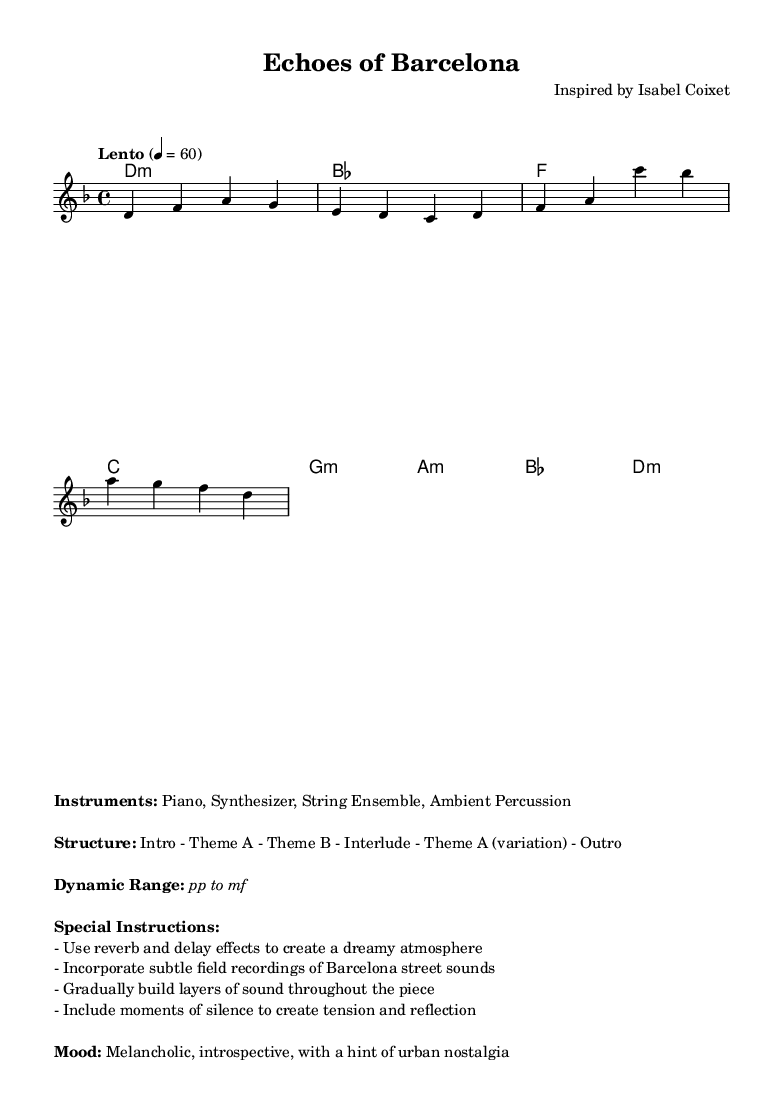What is the key signature of this music? The key signature is D minor, which contains one flat (B flat). This is indicated at the beginning of the staff.
Answer: D minor What is the time signature of this piece? The time signature is 4/4, as visible at the beginning of the score next to the key signature. This means there are four beats in each measure.
Answer: 4/4 What is the tempo indication for this composition? The tempo is marked "Lento," which indicates a slow tempo. The specific metronome marking is 4 = 60, meaning there should be 60 quarter note beats per minute.
Answer: Lento What instruments are specified for this arrangement? The instruments listed include Piano, Synthesizer, String Ensemble, and Ambient Percussion, as detailed in the markup section under "Instruments."
Answer: Piano, Synthesizer, String Ensemble, Ambient Percussion How many sections are in the structure of this piece? The structure includes six sections as outlined: Intro, Theme A, Theme B, Interlude, Theme A (variation), and Outro. This information is outlined in the markup under "Structure."
Answer: Six What mood is conveyed by the piece according to the description? The mood described is melancholic and introspective, with a hint of urban nostalgia, which captures the emotional intent of the music as per the markup.
Answer: Melancholic, introspective, with a hint of urban nostalgia What dynamic range is indicated in the music? The dynamic range specified is from pianissimo (pp) to mezzoforte (mf), reflecting the soft to moderately loud dynamics intended for this piece. This is mentioned in the markup section.
Answer: pp to mf 